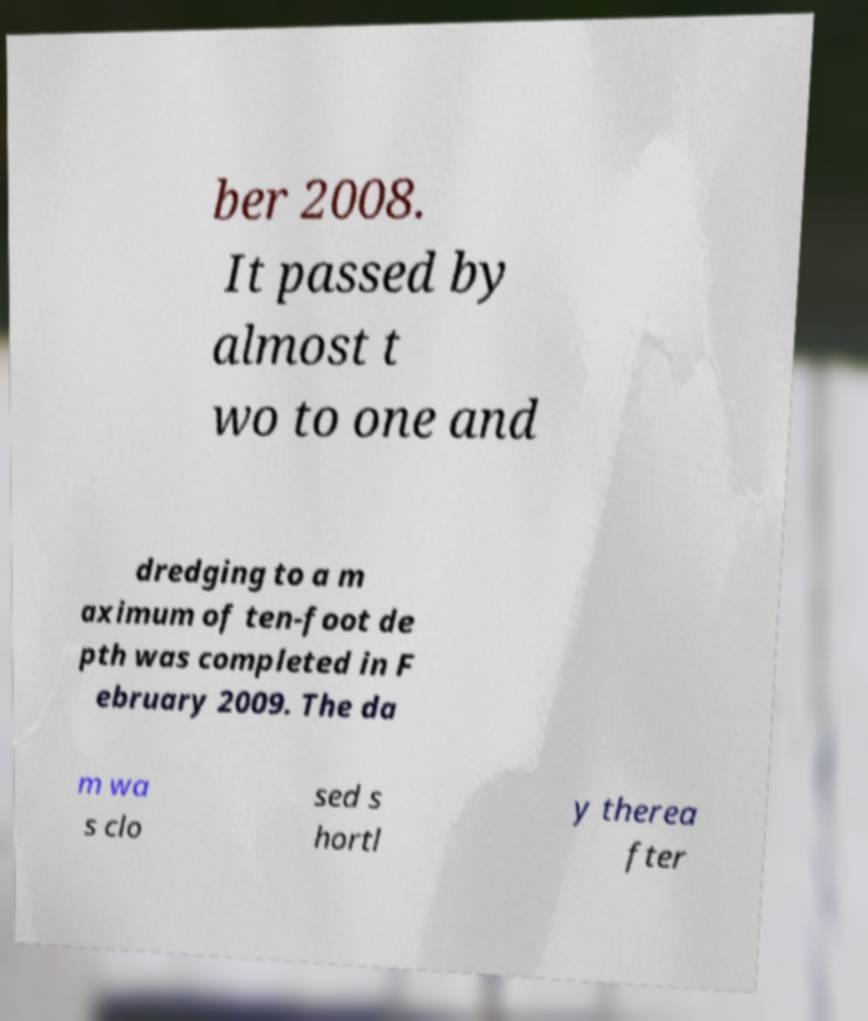Please read and relay the text visible in this image. What does it say? ber 2008. It passed by almost t wo to one and dredging to a m aximum of ten-foot de pth was completed in F ebruary 2009. The da m wa s clo sed s hortl y therea fter 